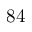<formula> <loc_0><loc_0><loc_500><loc_500>8 4</formula> 